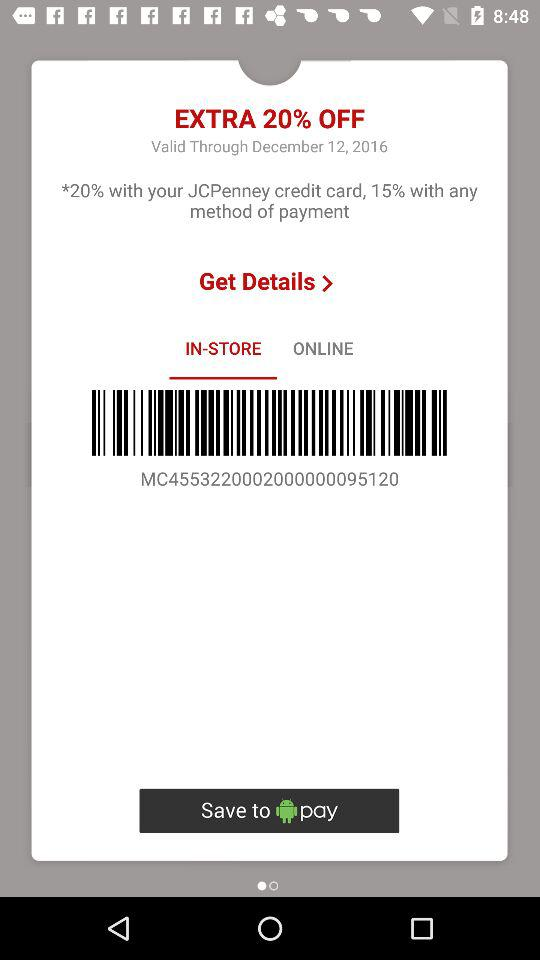How much is it online?
When the provided information is insufficient, respond with <no answer>. <no answer> 